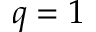Convert formula to latex. <formula><loc_0><loc_0><loc_500><loc_500>q = 1</formula> 